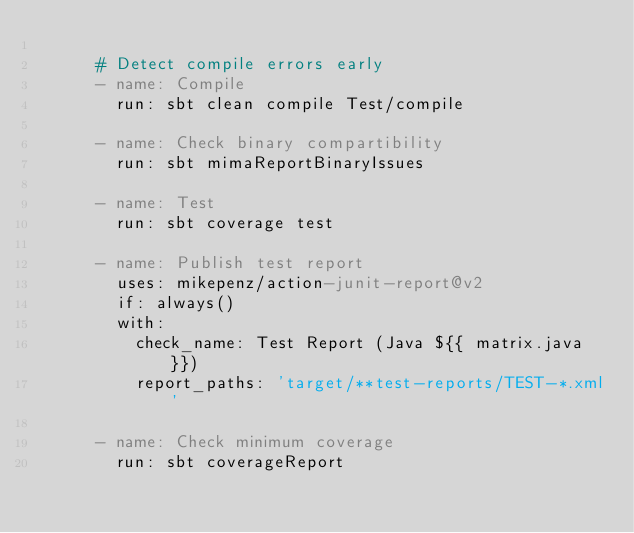Convert code to text. <code><loc_0><loc_0><loc_500><loc_500><_YAML_>
      # Detect compile errors early
      - name: Compile
        run: sbt clean compile Test/compile

      - name: Check binary compartibility
        run: sbt mimaReportBinaryIssues

      - name: Test
        run: sbt coverage test

      - name: Publish test report
        uses: mikepenz/action-junit-report@v2
        if: always()
        with:
          check_name: Test Report (Java ${{ matrix.java }})
          report_paths: 'target/**test-reports/TEST-*.xml'

      - name: Check minimum coverage
        run: sbt coverageReport
</code> 